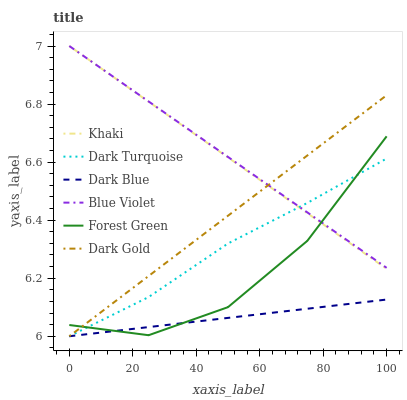Does Dark Blue have the minimum area under the curve?
Answer yes or no. Yes. Does Blue Violet have the maximum area under the curve?
Answer yes or no. Yes. Does Dark Gold have the minimum area under the curve?
Answer yes or no. No. Does Dark Gold have the maximum area under the curve?
Answer yes or no. No. Is Khaki the smoothest?
Answer yes or no. Yes. Is Forest Green the roughest?
Answer yes or no. Yes. Is Dark Gold the smoothest?
Answer yes or no. No. Is Dark Gold the roughest?
Answer yes or no. No. Does Forest Green have the lowest value?
Answer yes or no. No. Does Dark Gold have the highest value?
Answer yes or no. No. Is Dark Blue less than Khaki?
Answer yes or no. Yes. Is Khaki greater than Dark Blue?
Answer yes or no. Yes. Does Dark Blue intersect Khaki?
Answer yes or no. No. 